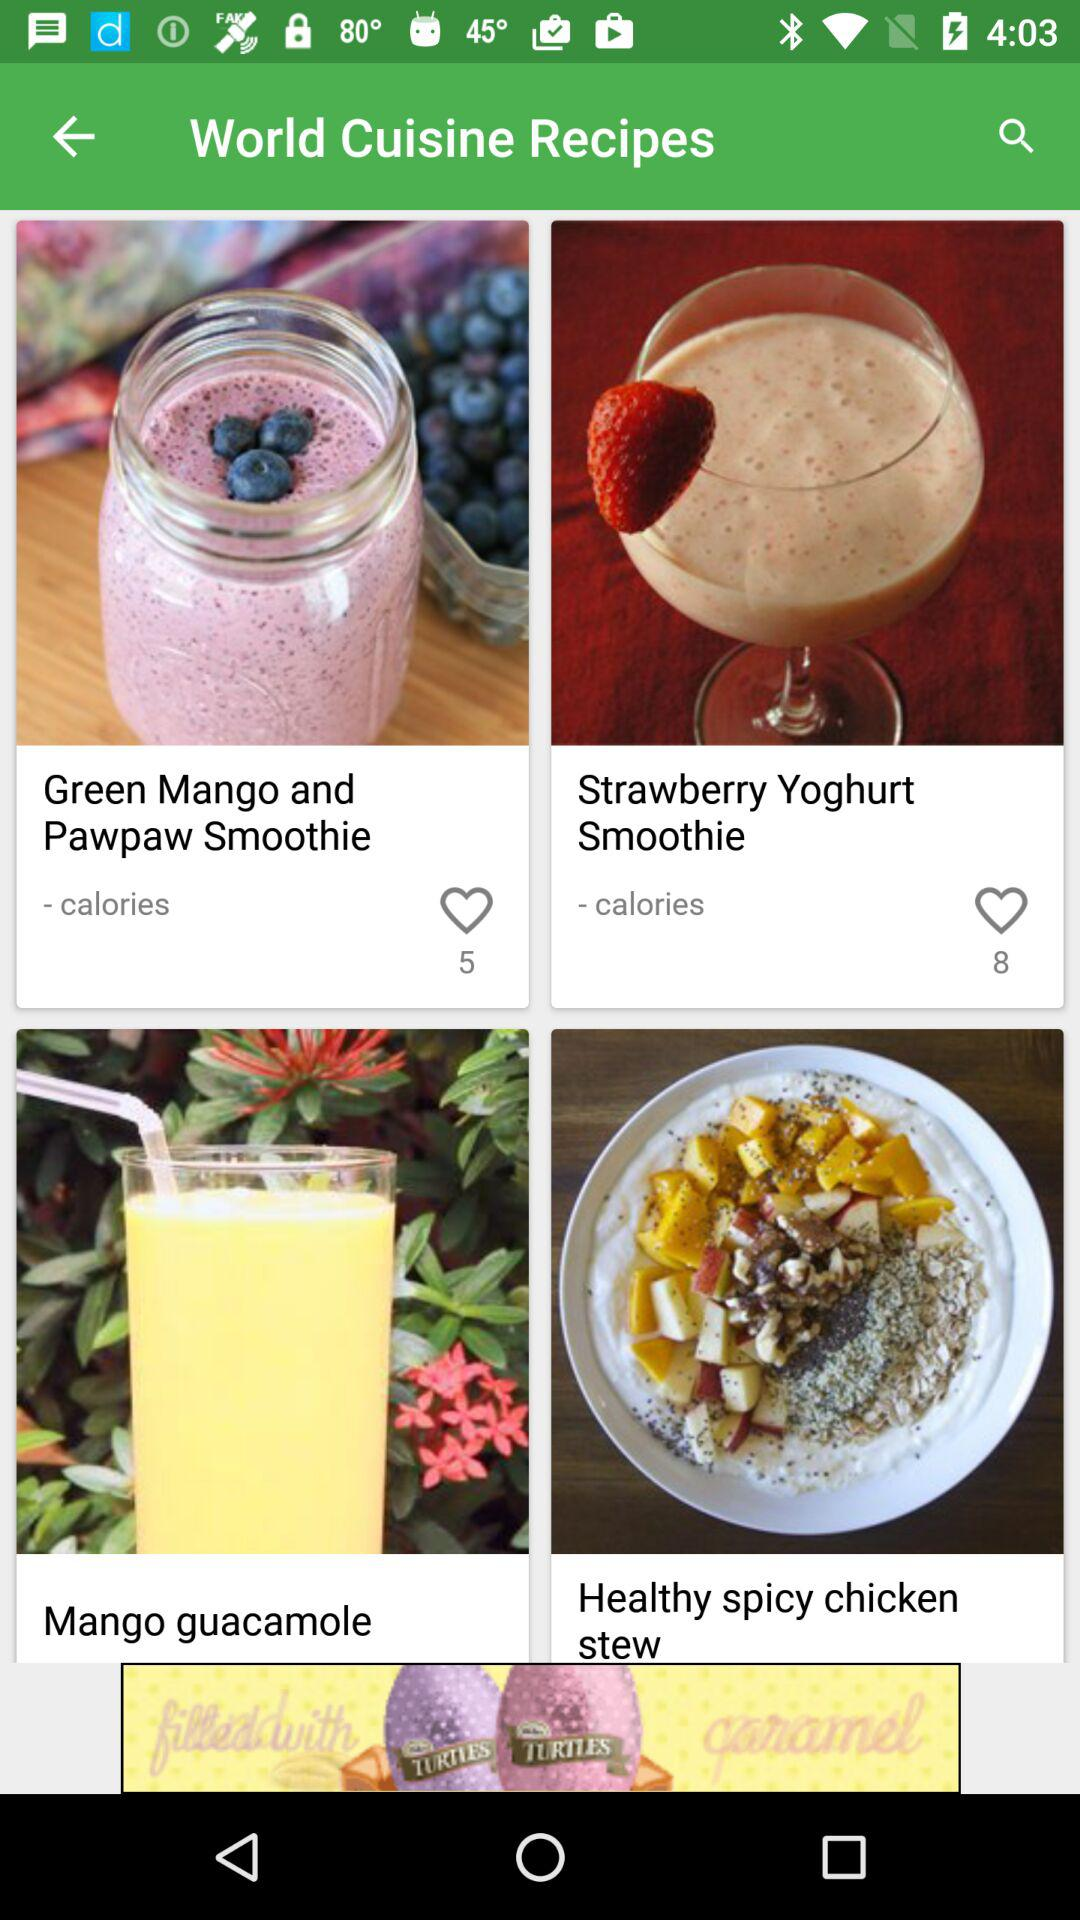How many recipes have a heart?
Answer the question using a single word or phrase. 2 